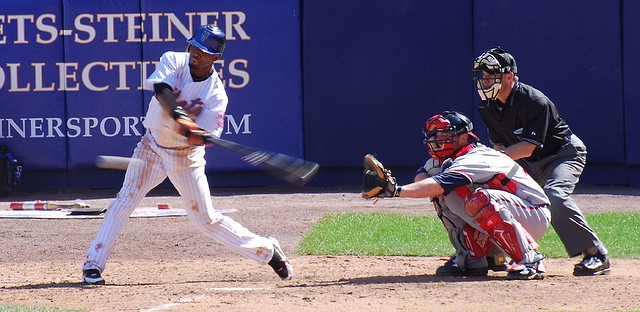<image>What team does the batter play for? I am not sure what team the batter plays for. It could be 'mets' or 'yankees'. What team does the batter play for? I don't know what team does the batter play for. It could be 'jets', 'mets', 'yankees' or any other team. 